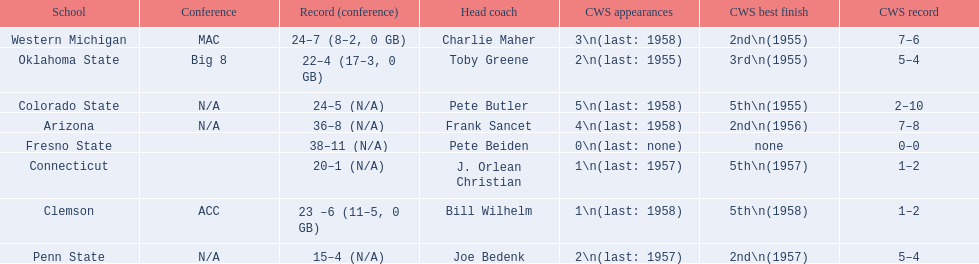What are all the school names? Arizona, Clemson, Colorado State, Connecticut, Fresno State, Oklahoma State, Penn State, Western Michigan. What is the record for each? 36–8 (N/A), 23 –6 (11–5, 0 GB), 24–5 (N/A), 20–1 (N/A), 38–11 (N/A), 22–4 (17–3, 0 GB), 15–4 (N/A), 24–7 (8–2, 0 GB). Which school had the fewest number of wins? Penn State. 